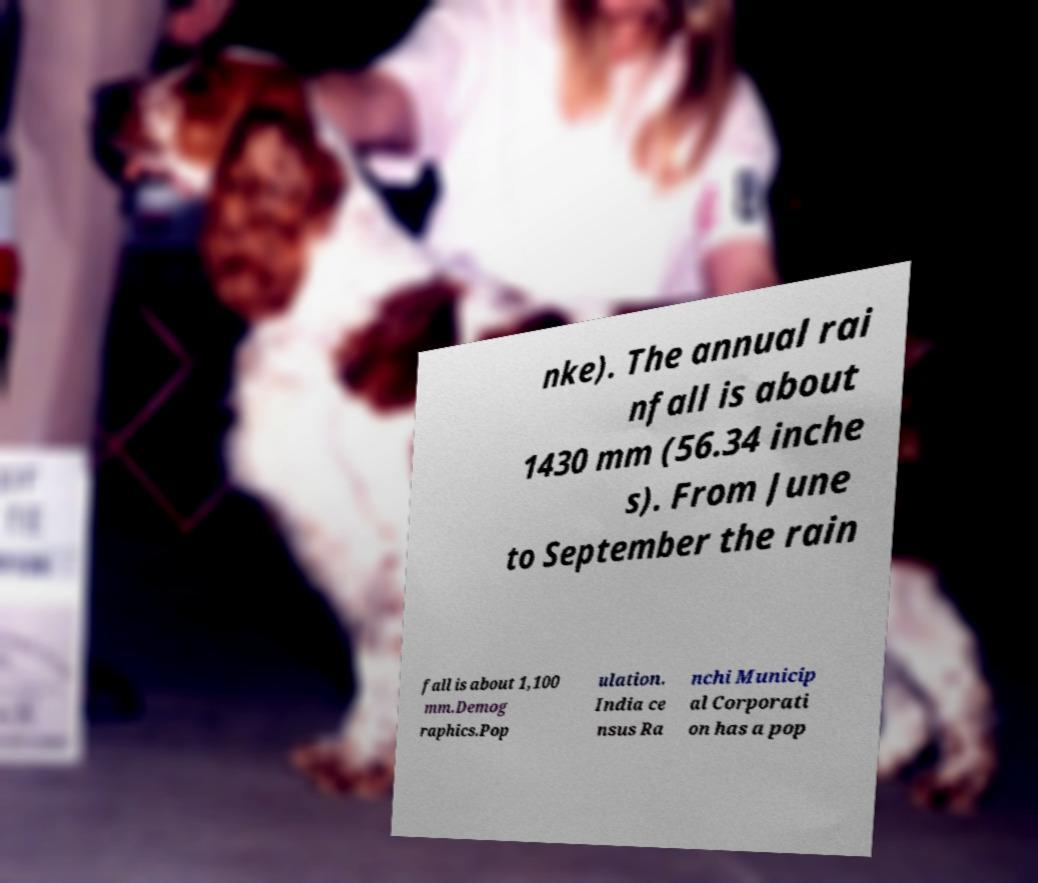Could you assist in decoding the text presented in this image and type it out clearly? nke). The annual rai nfall is about 1430 mm (56.34 inche s). From June to September the rain fall is about 1,100 mm.Demog raphics.Pop ulation. India ce nsus Ra nchi Municip al Corporati on has a pop 